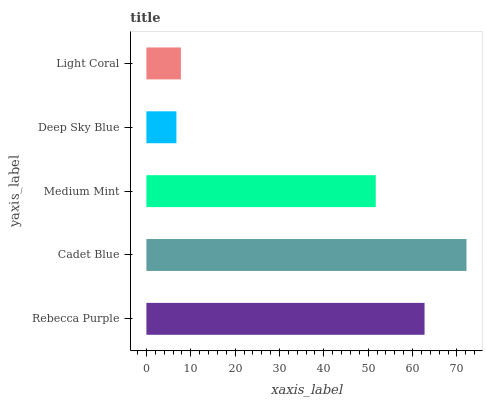Is Deep Sky Blue the minimum?
Answer yes or no. Yes. Is Cadet Blue the maximum?
Answer yes or no. Yes. Is Medium Mint the minimum?
Answer yes or no. No. Is Medium Mint the maximum?
Answer yes or no. No. Is Cadet Blue greater than Medium Mint?
Answer yes or no. Yes. Is Medium Mint less than Cadet Blue?
Answer yes or no. Yes. Is Medium Mint greater than Cadet Blue?
Answer yes or no. No. Is Cadet Blue less than Medium Mint?
Answer yes or no. No. Is Medium Mint the high median?
Answer yes or no. Yes. Is Medium Mint the low median?
Answer yes or no. Yes. Is Light Coral the high median?
Answer yes or no. No. Is Light Coral the low median?
Answer yes or no. No. 